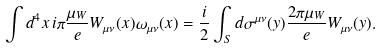<formula> <loc_0><loc_0><loc_500><loc_500>\int d ^ { 4 } x \, i \pi \frac { \mu _ { W } } e W _ { \mu \nu } ( x ) \omega _ { \mu \nu } ( x ) = \frac { i } { 2 } \int _ { S } d \sigma ^ { \mu \nu } ( y ) \frac { 2 \pi \mu _ { W } } e W _ { \mu \nu } ( y ) .</formula> 